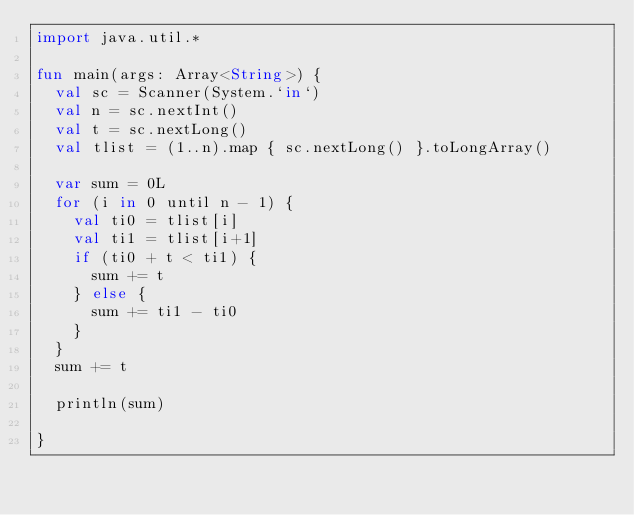Convert code to text. <code><loc_0><loc_0><loc_500><loc_500><_Kotlin_>import java.util.*

fun main(args: Array<String>) {
  val sc = Scanner(System.`in`)
  val n = sc.nextInt()
  val t = sc.nextLong()
  val tlist = (1..n).map { sc.nextLong() }.toLongArray()

  var sum = 0L
  for (i in 0 until n - 1) {
    val ti0 = tlist[i]
    val ti1 = tlist[i+1]
    if (ti0 + t < ti1) {
      sum += t
    } else {
      sum += ti1 - ti0
    }
  }
  sum += t

  println(sum)

}
</code> 